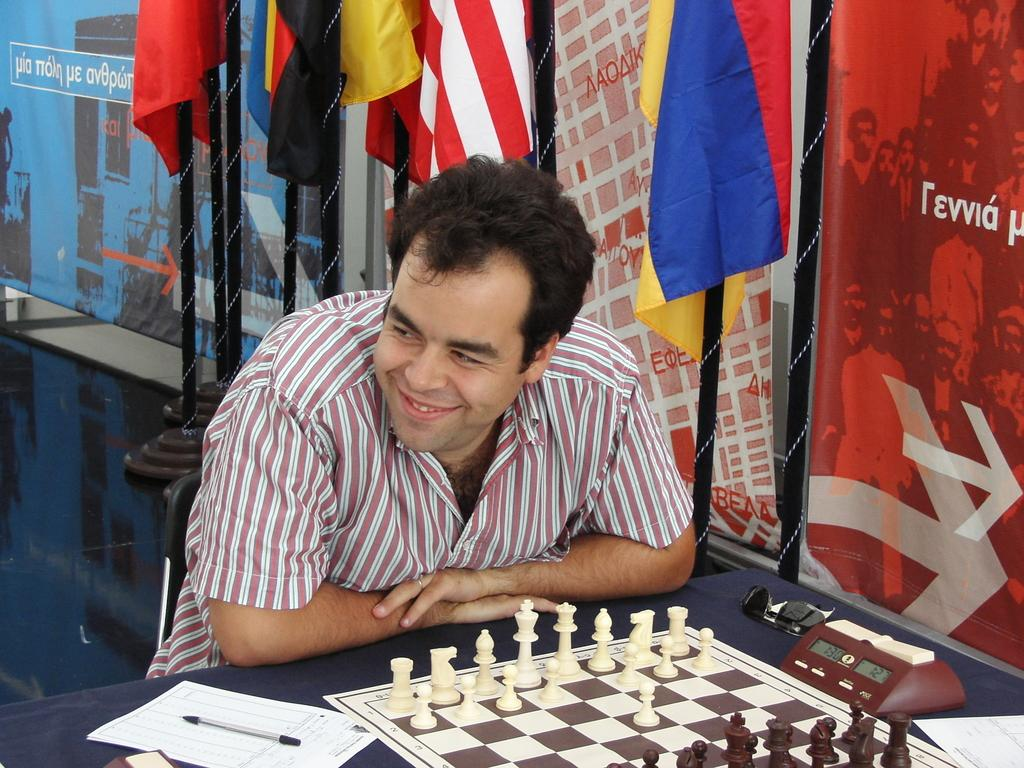Who is in front of the table in the image? There is a person in front of the table in the image. What is on the table? The table contains a chess board, sunglasses, a timer, papers, and a pen. What might be used to keep track of time during a game or activity? There is a timer on the table. What is the purpose of the flag poles at the top of the image? The purpose of the flag poles at the top of the image is not clear from the provided facts. What language is being spoken by the person in the image? The provided facts do not mention any language being spoken in the image. Is there a war being depicted in the image? There is no indication of a war in the image. 